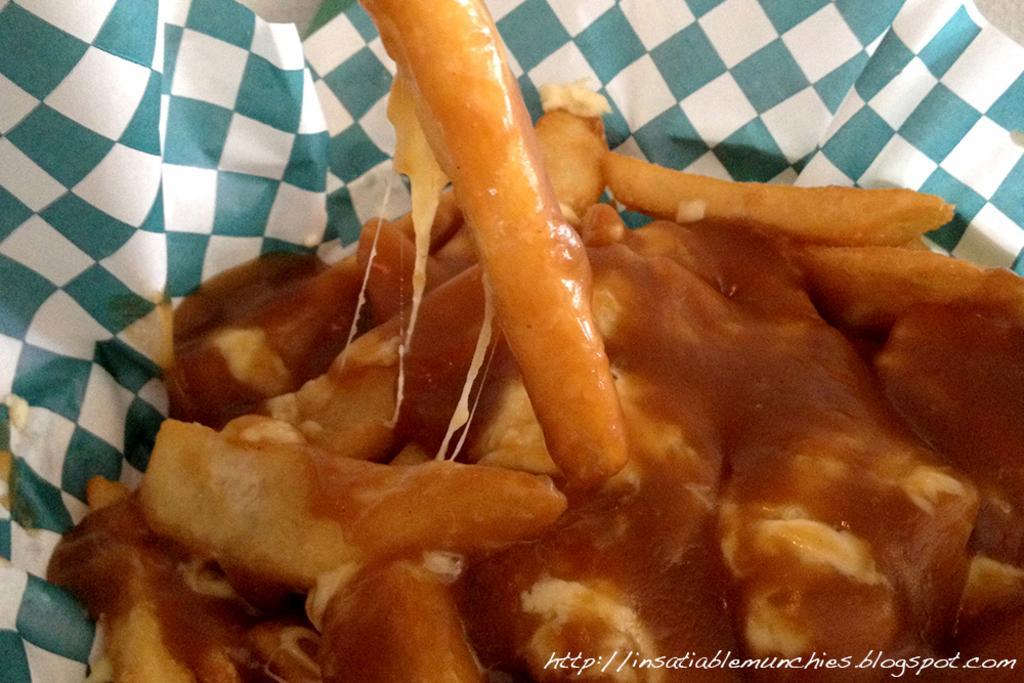Could you give a brief overview of what you see in this image? In the center of the image we can see one paper, which is in green and white color. In the paper, we can see some food item. At the bottom right side of the image, we can see some text. In the background we can see a few other objects. 